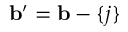Convert formula to latex. <formula><loc_0><loc_0><loc_500><loc_500>b ^ { \prime } = b - \{ j \}</formula> 